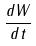<formula> <loc_0><loc_0><loc_500><loc_500>\frac { d W } { d t }</formula> 